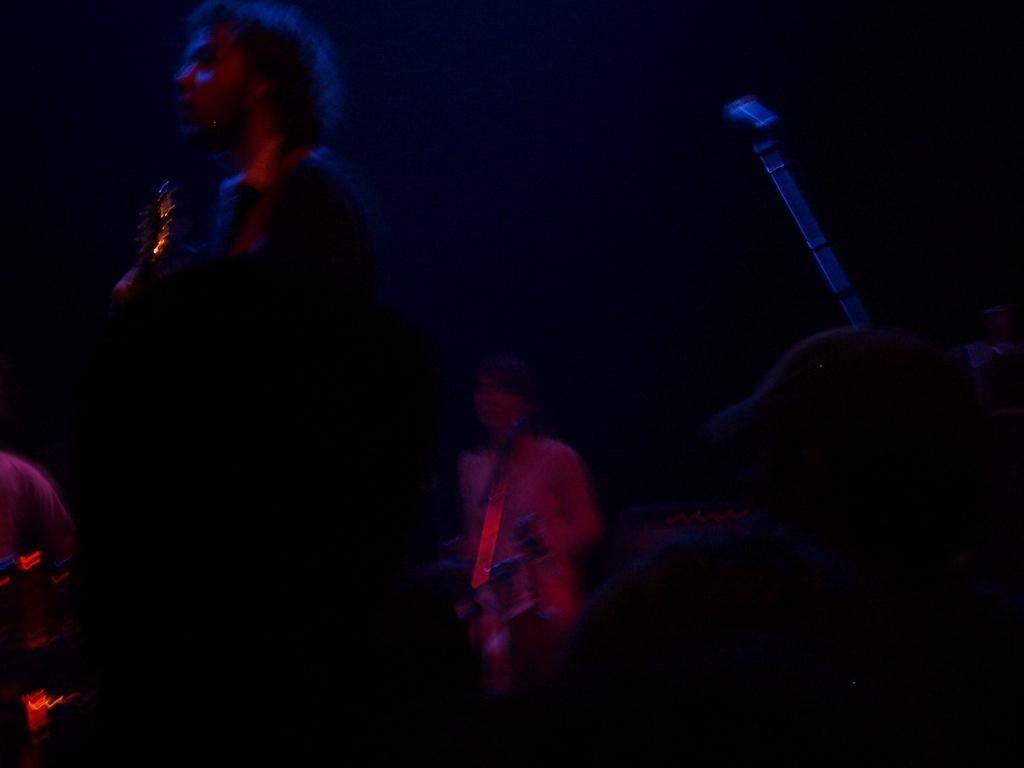Please provide a concise description of this image. In the picture we can see some people are standing and holding a guitar and beside them we can see some musical instrument. 